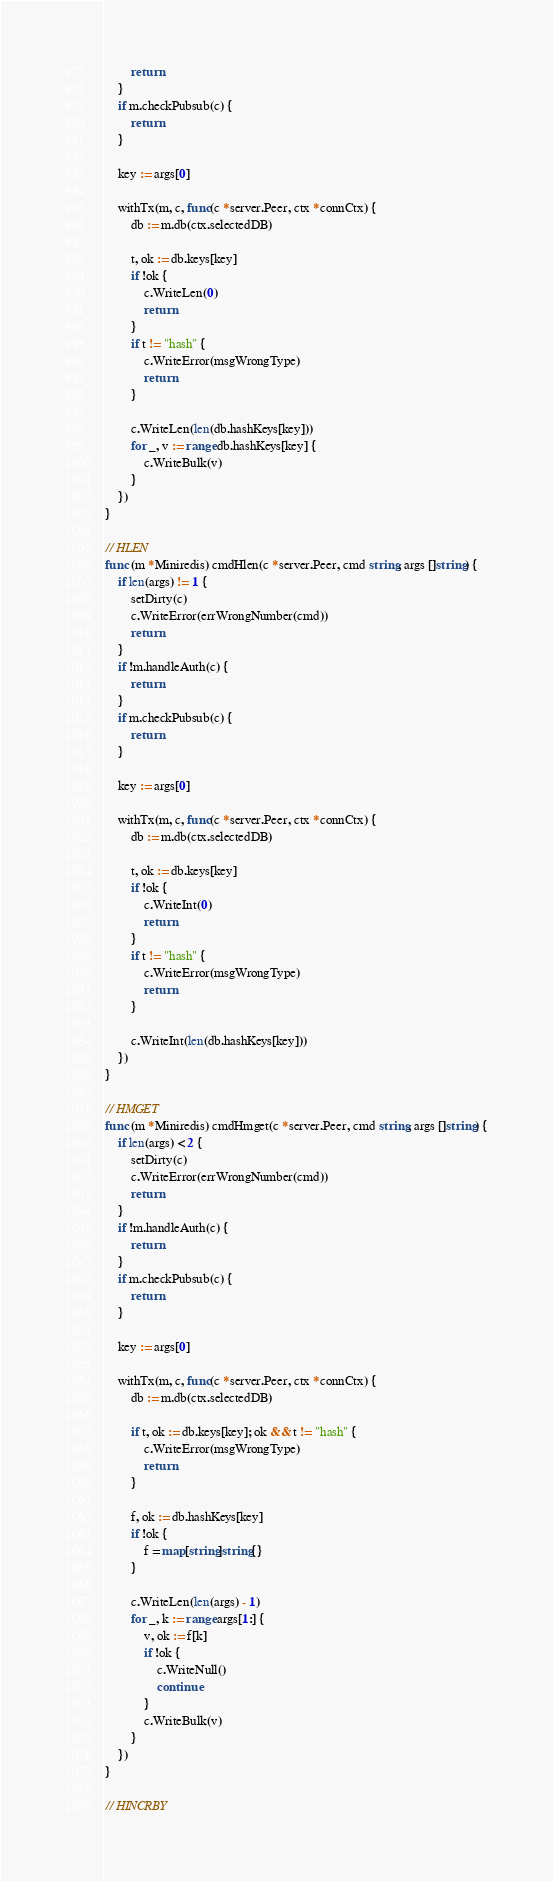<code> <loc_0><loc_0><loc_500><loc_500><_Go_>		return
	}
	if m.checkPubsub(c) {
		return
	}

	key := args[0]

	withTx(m, c, func(c *server.Peer, ctx *connCtx) {
		db := m.db(ctx.selectedDB)

		t, ok := db.keys[key]
		if !ok {
			c.WriteLen(0)
			return
		}
		if t != "hash" {
			c.WriteError(msgWrongType)
			return
		}

		c.WriteLen(len(db.hashKeys[key]))
		for _, v := range db.hashKeys[key] {
			c.WriteBulk(v)
		}
	})
}

// HLEN
func (m *Miniredis) cmdHlen(c *server.Peer, cmd string, args []string) {
	if len(args) != 1 {
		setDirty(c)
		c.WriteError(errWrongNumber(cmd))
		return
	}
	if !m.handleAuth(c) {
		return
	}
	if m.checkPubsub(c) {
		return
	}

	key := args[0]

	withTx(m, c, func(c *server.Peer, ctx *connCtx) {
		db := m.db(ctx.selectedDB)

		t, ok := db.keys[key]
		if !ok {
			c.WriteInt(0)
			return
		}
		if t != "hash" {
			c.WriteError(msgWrongType)
			return
		}

		c.WriteInt(len(db.hashKeys[key]))
	})
}

// HMGET
func (m *Miniredis) cmdHmget(c *server.Peer, cmd string, args []string) {
	if len(args) < 2 {
		setDirty(c)
		c.WriteError(errWrongNumber(cmd))
		return
	}
	if !m.handleAuth(c) {
		return
	}
	if m.checkPubsub(c) {
		return
	}

	key := args[0]

	withTx(m, c, func(c *server.Peer, ctx *connCtx) {
		db := m.db(ctx.selectedDB)

		if t, ok := db.keys[key]; ok && t != "hash" {
			c.WriteError(msgWrongType)
			return
		}

		f, ok := db.hashKeys[key]
		if !ok {
			f = map[string]string{}
		}

		c.WriteLen(len(args) - 1)
		for _, k := range args[1:] {
			v, ok := f[k]
			if !ok {
				c.WriteNull()
				continue
			}
			c.WriteBulk(v)
		}
	})
}

// HINCRBY</code> 